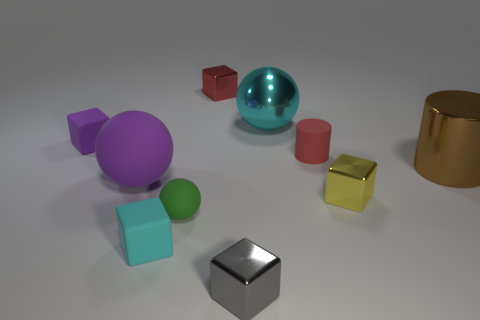Is the cyan cube the same size as the gray object?
Your response must be concise. Yes. There is a big cylinder that is the same material as the tiny gray object; what color is it?
Offer a terse response. Brown. The tiny metal thing that is the same color as the small rubber cylinder is what shape?
Provide a short and direct response. Cube. Are there the same number of purple things that are in front of the rubber cylinder and small yellow shiny cubes to the left of the purple block?
Your response must be concise. No. What is the shape of the cyan thing behind the large sphere that is to the left of the metallic sphere?
Keep it short and to the point. Sphere. There is a cyan thing that is the same shape as the tiny purple thing; what is it made of?
Keep it short and to the point. Rubber. There is another metallic sphere that is the same size as the purple ball; what color is it?
Offer a very short reply. Cyan. Are there the same number of purple rubber cubes that are to the right of the rubber cylinder and cyan things?
Keep it short and to the point. No. There is a rubber cube in front of the matte object that is to the left of the big matte thing; what color is it?
Offer a terse response. Cyan. How big is the cyan thing that is right of the tiny shiny block behind the big cylinder?
Keep it short and to the point. Large. 